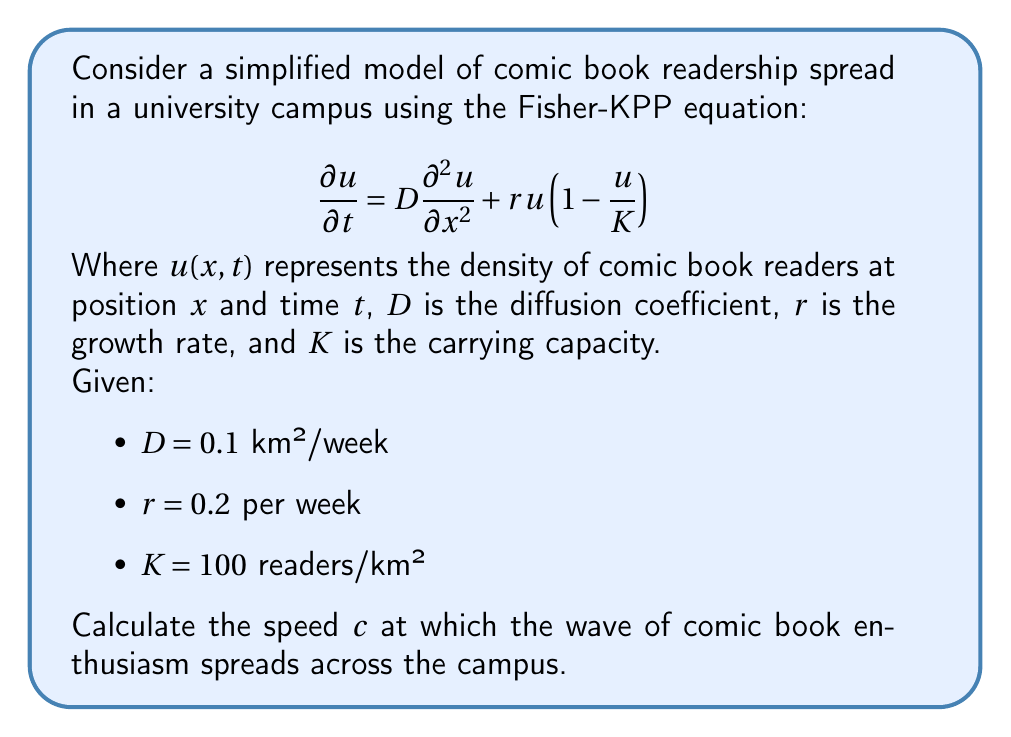Give your solution to this math problem. To solve this problem, we'll use the Fisher-KPP equation, which is a reaction-diffusion equation commonly used to model population dynamics.

1) For the Fisher-KPP equation, the speed of the traveling wave is given by:

   $$c = 2\sqrt{rD}$$

2) We're given the following values:
   - $D = 0.1$ km²/week (diffusion coefficient)
   - $r = 0.2$ per week (growth rate)

3) Let's substitute these values into the equation:

   $$c = 2\sqrt{(0.2)(0.1)}$$

4) Simplify under the square root:

   $$c = 2\sqrt{0.02}$$

5) Calculate the square root:

   $$c = 2(0.1414)$$

6) Multiply:

   $$c = 0.2828$$ km/week

7) To express this in a more practical unit, let's convert to meters per day:

   $0.2828$ km/week * (1000 m / 1 km) * (1 week / 7 days) ≈ 40.4 m/day

This result means that the wave of comic book enthusiasm spreads across the campus at a speed of approximately 40.4 meters per day.

Note: The carrying capacity $K$ doesn't affect the speed of the wave in this model, but it determines the maximum density of readers that can be reached.
Answer: The speed at which the wave of comic book enthusiasm spreads across the campus is approximately 0.2828 km/week or 40.4 m/day. 